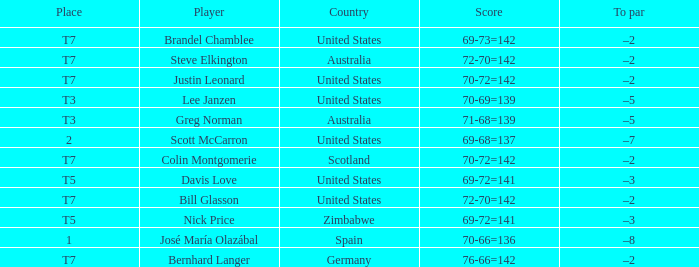WHich Score has a To par of –3, and a Country of united states? 69-72=141. 